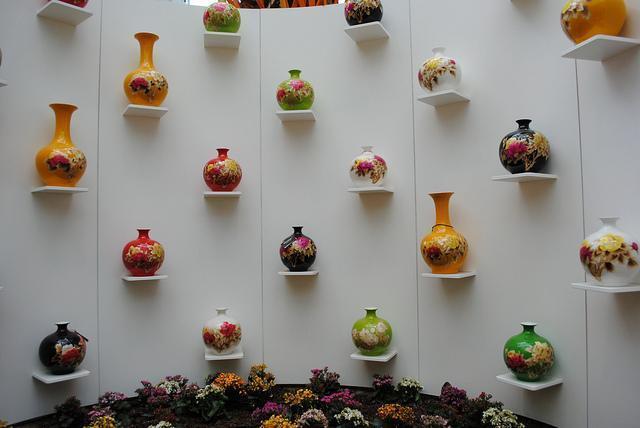How many vases are there?
Give a very brief answer. 5. 